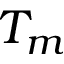Convert formula to latex. <formula><loc_0><loc_0><loc_500><loc_500>T _ { m }</formula> 